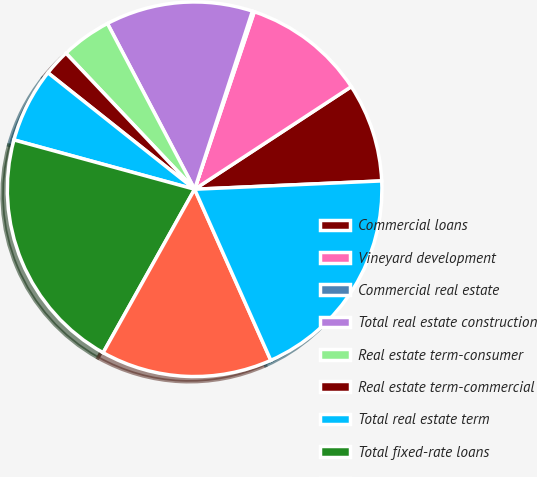Convert chart. <chart><loc_0><loc_0><loc_500><loc_500><pie_chart><fcel>Commercial loans<fcel>Vineyard development<fcel>Commercial real estate<fcel>Total real estate construction<fcel>Real estate term-consumer<fcel>Real estate term-commercial<fcel>Total real estate term<fcel>Total fixed-rate loans<fcel>Consumer and other<fcel>Total variable-rate loans<nl><fcel>8.52%<fcel>10.61%<fcel>0.17%<fcel>12.7%<fcel>4.35%<fcel>2.26%<fcel>6.44%<fcel>21.12%<fcel>14.79%<fcel>19.04%<nl></chart> 